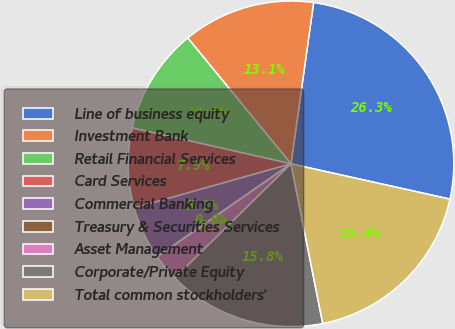Convert chart to OTSL. <chart><loc_0><loc_0><loc_500><loc_500><pie_chart><fcel>Line of business equity<fcel>Investment Bank<fcel>Retail Financial Services<fcel>Card Services<fcel>Commercial Banking<fcel>Treasury & Securities Services<fcel>Asset Management<fcel>Corporate/Private Equity<fcel>Total common stockholders'<nl><fcel>26.26%<fcel>13.15%<fcel>10.53%<fcel>7.91%<fcel>5.28%<fcel>0.04%<fcel>2.66%<fcel>15.77%<fcel>18.4%<nl></chart> 